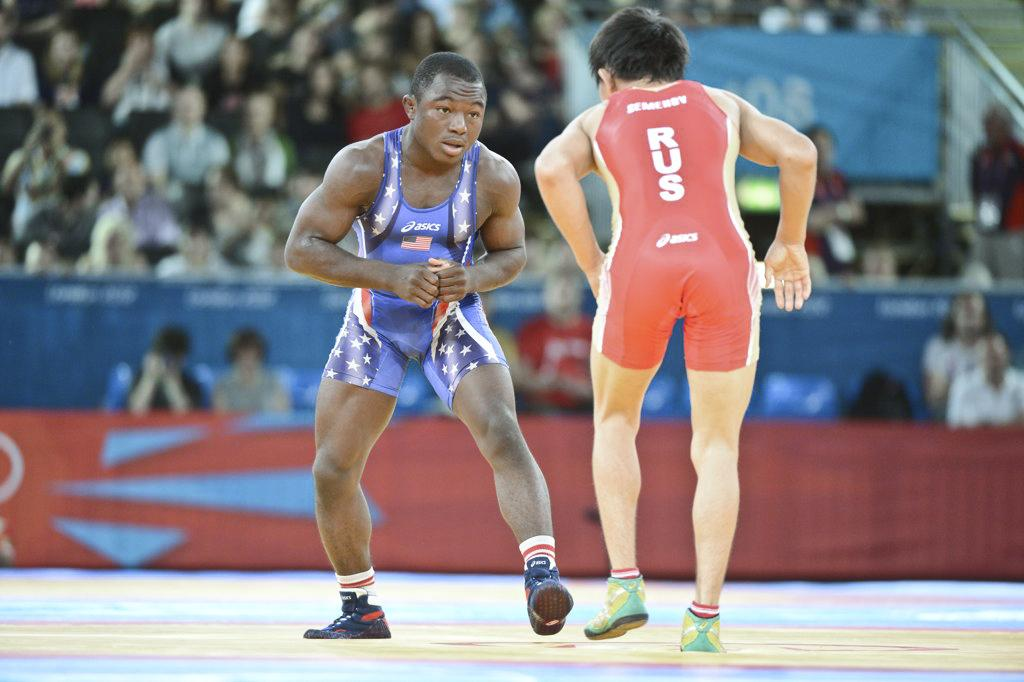<image>
Render a clear and concise summary of the photo. A wrestler competes as his singlet proclaims his Russian heritage. 